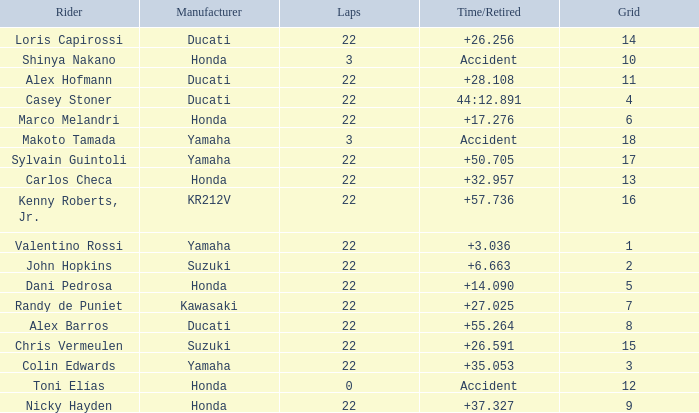What is the average grid for the competitiors who had laps smaller than 3? 12.0. 